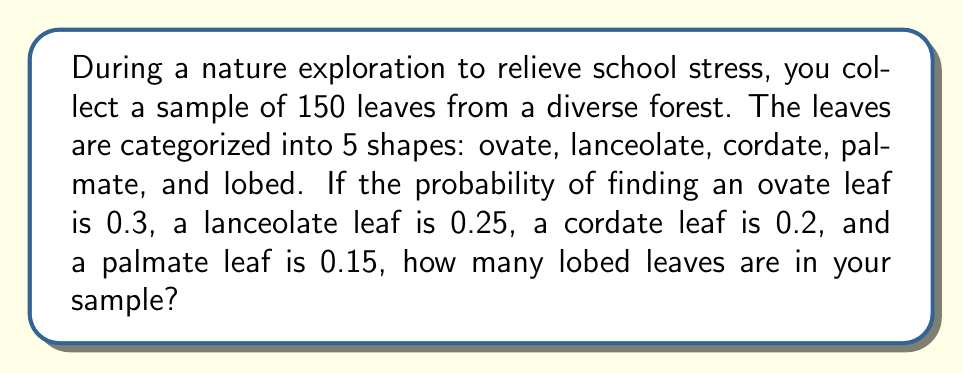Can you solve this math problem? Let's approach this step-by-step:

1) First, we need to understand that the probabilities of all leaf shapes must sum to 1.
   Let $x$ be the probability of finding a lobed leaf.
   
   $0.3 + 0.25 + 0.2 + 0.15 + x = 1$

2) Solve for $x$:
   $0.9 + x = 1$
   $x = 1 - 0.9 = 0.1$

3) So, the probability of finding a lobed leaf is 0.1 or 10%.

4) Now, we can calculate the expected number of each leaf shape in our sample of 150 leaves:

   Ovate: $150 \times 0.3 = 45$
   Lanceolate: $150 \times 0.25 = 37.5$
   Cordate: $150 \times 0.2 = 30$
   Palmate: $150 \times 0.15 = 22.5$
   Lobed: $150 \times 0.1 = 15$

5) Since we can't have fractional leaves, we round these to the nearest whole number:

   Ovate: 45
   Lanceolate: 38
   Cordate: 30
   Palmate: 23
   Lobed: 15

Therefore, there are 15 lobed leaves in the sample.
Answer: 15 